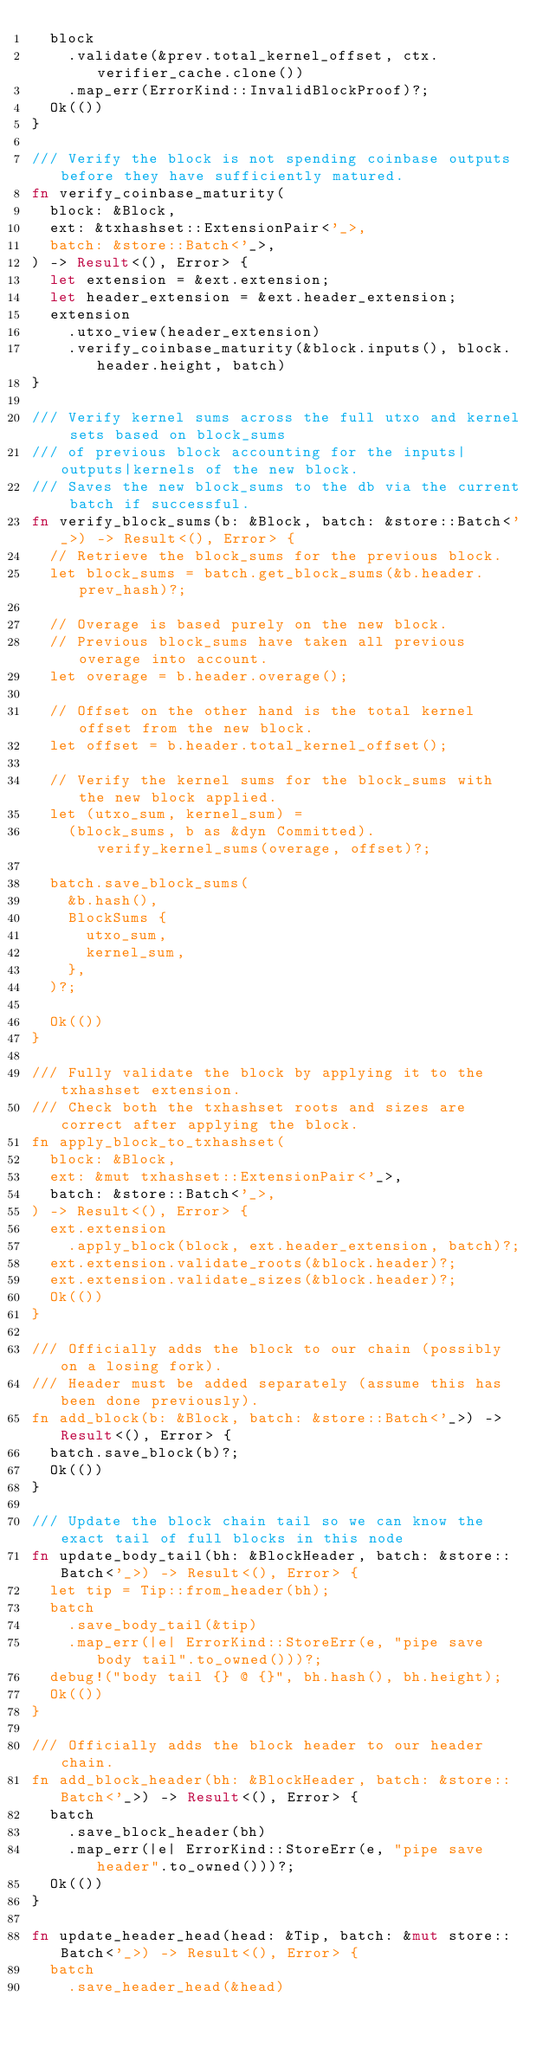<code> <loc_0><loc_0><loc_500><loc_500><_Rust_>	block
		.validate(&prev.total_kernel_offset, ctx.verifier_cache.clone())
		.map_err(ErrorKind::InvalidBlockProof)?;
	Ok(())
}

/// Verify the block is not spending coinbase outputs before they have sufficiently matured.
fn verify_coinbase_maturity(
	block: &Block,
	ext: &txhashset::ExtensionPair<'_>,
	batch: &store::Batch<'_>,
) -> Result<(), Error> {
	let extension = &ext.extension;
	let header_extension = &ext.header_extension;
	extension
		.utxo_view(header_extension)
		.verify_coinbase_maturity(&block.inputs(), block.header.height, batch)
}

/// Verify kernel sums across the full utxo and kernel sets based on block_sums
/// of previous block accounting for the inputs|outputs|kernels of the new block.
/// Saves the new block_sums to the db via the current batch if successful.
fn verify_block_sums(b: &Block, batch: &store::Batch<'_>) -> Result<(), Error> {
	// Retrieve the block_sums for the previous block.
	let block_sums = batch.get_block_sums(&b.header.prev_hash)?;

	// Overage is based purely on the new block.
	// Previous block_sums have taken all previous overage into account.
	let overage = b.header.overage();

	// Offset on the other hand is the total kernel offset from the new block.
	let offset = b.header.total_kernel_offset();

	// Verify the kernel sums for the block_sums with the new block applied.
	let (utxo_sum, kernel_sum) =
		(block_sums, b as &dyn Committed).verify_kernel_sums(overage, offset)?;

	batch.save_block_sums(
		&b.hash(),
		BlockSums {
			utxo_sum,
			kernel_sum,
		},
	)?;

	Ok(())
}

/// Fully validate the block by applying it to the txhashset extension.
/// Check both the txhashset roots and sizes are correct after applying the block.
fn apply_block_to_txhashset(
	block: &Block,
	ext: &mut txhashset::ExtensionPair<'_>,
	batch: &store::Batch<'_>,
) -> Result<(), Error> {
	ext.extension
		.apply_block(block, ext.header_extension, batch)?;
	ext.extension.validate_roots(&block.header)?;
	ext.extension.validate_sizes(&block.header)?;
	Ok(())
}

/// Officially adds the block to our chain (possibly on a losing fork).
/// Header must be added separately (assume this has been done previously).
fn add_block(b: &Block, batch: &store::Batch<'_>) -> Result<(), Error> {
	batch.save_block(b)?;
	Ok(())
}

/// Update the block chain tail so we can know the exact tail of full blocks in this node
fn update_body_tail(bh: &BlockHeader, batch: &store::Batch<'_>) -> Result<(), Error> {
	let tip = Tip::from_header(bh);
	batch
		.save_body_tail(&tip)
		.map_err(|e| ErrorKind::StoreErr(e, "pipe save body tail".to_owned()))?;
	debug!("body tail {} @ {}", bh.hash(), bh.height);
	Ok(())
}

/// Officially adds the block header to our header chain.
fn add_block_header(bh: &BlockHeader, batch: &store::Batch<'_>) -> Result<(), Error> {
	batch
		.save_block_header(bh)
		.map_err(|e| ErrorKind::StoreErr(e, "pipe save header".to_owned()))?;
	Ok(())
}

fn update_header_head(head: &Tip, batch: &mut store::Batch<'_>) -> Result<(), Error> {
	batch
		.save_header_head(&head)</code> 